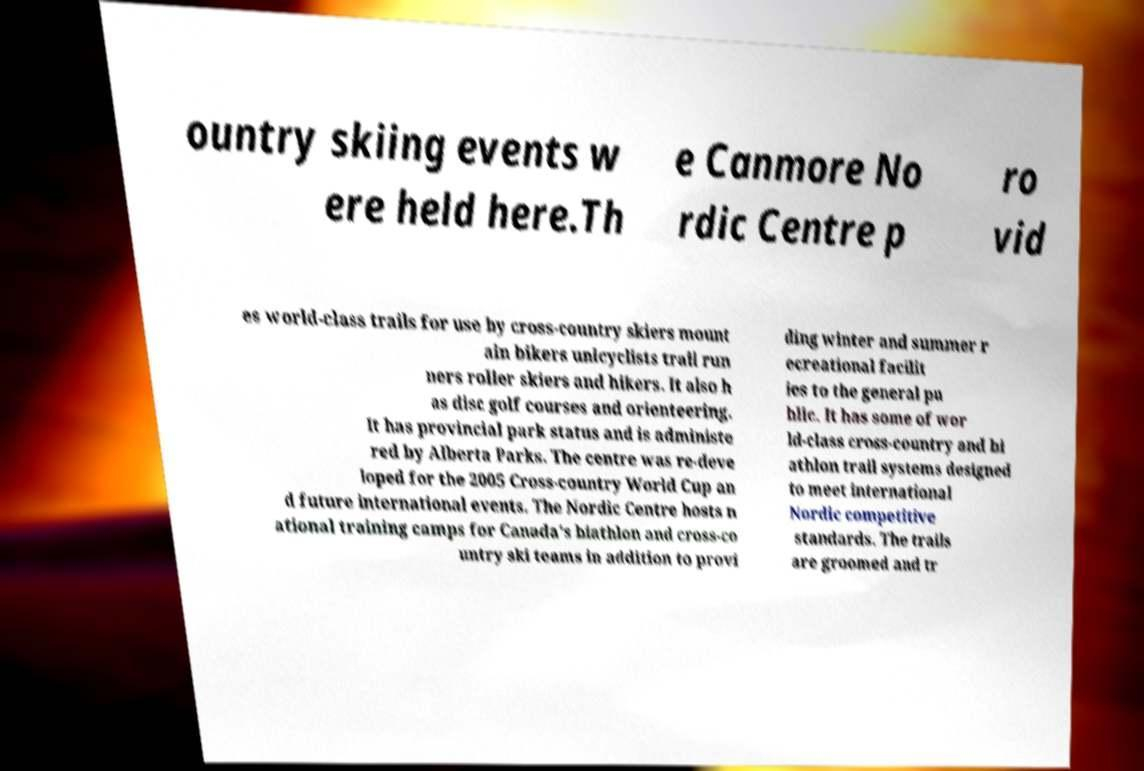What messages or text are displayed in this image? I need them in a readable, typed format. ountry skiing events w ere held here.Th e Canmore No rdic Centre p ro vid es world-class trails for use by cross-country skiers mount ain bikers unicyclists trail run ners roller skiers and hikers. It also h as disc golf courses and orienteering. It has provincial park status and is administe red by Alberta Parks. The centre was re-deve loped for the 2005 Cross-country World Cup an d future international events. The Nordic Centre hosts n ational training camps for Canada's biathlon and cross-co untry ski teams in addition to provi ding winter and summer r ecreational facilit ies to the general pu blic. It has some of wor ld-class cross-country and bi athlon trail systems designed to meet international Nordic competitive standards. The trails are groomed and tr 